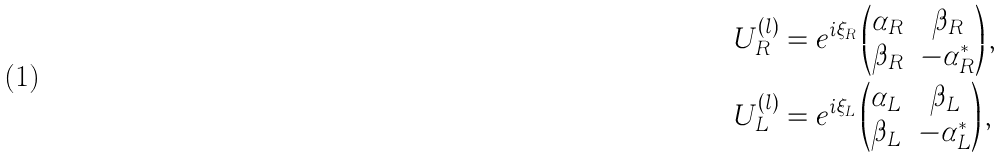<formula> <loc_0><loc_0><loc_500><loc_500>U _ { R } ^ { ( l ) } & = e ^ { i \xi _ { R } } \begin{pmatrix} \alpha _ { R } & \beta _ { R } \\ \beta _ { R } & - \alpha _ { R } ^ { \ast } \end{pmatrix} , \\ U _ { L } ^ { ( l ) } & = e ^ { i \xi _ { L } } \begin{pmatrix} \alpha _ { L } & \beta _ { L } \\ \beta _ { L } & - \alpha _ { L } ^ { \ast } \end{pmatrix} ,</formula> 